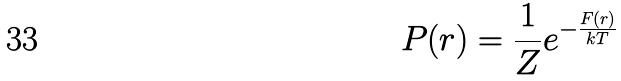Convert formula to latex. <formula><loc_0><loc_0><loc_500><loc_500>P ( r ) = \frac { 1 } { Z } e ^ { - \frac { F ( r ) } { k T } }</formula> 